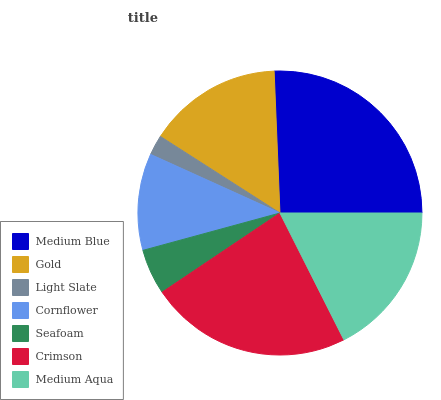Is Light Slate the minimum?
Answer yes or no. Yes. Is Medium Blue the maximum?
Answer yes or no. Yes. Is Gold the minimum?
Answer yes or no. No. Is Gold the maximum?
Answer yes or no. No. Is Medium Blue greater than Gold?
Answer yes or no. Yes. Is Gold less than Medium Blue?
Answer yes or no. Yes. Is Gold greater than Medium Blue?
Answer yes or no. No. Is Medium Blue less than Gold?
Answer yes or no. No. Is Gold the high median?
Answer yes or no. Yes. Is Gold the low median?
Answer yes or no. Yes. Is Medium Aqua the high median?
Answer yes or no. No. Is Medium Blue the low median?
Answer yes or no. No. 